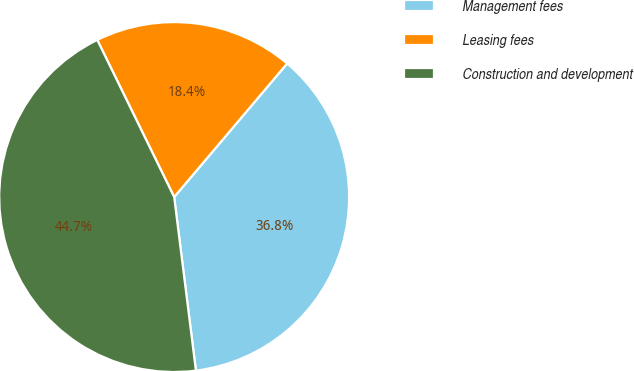Convert chart. <chart><loc_0><loc_0><loc_500><loc_500><pie_chart><fcel>Management fees<fcel>Leasing fees<fcel>Construction and development<nl><fcel>36.84%<fcel>18.42%<fcel>44.74%<nl></chart> 